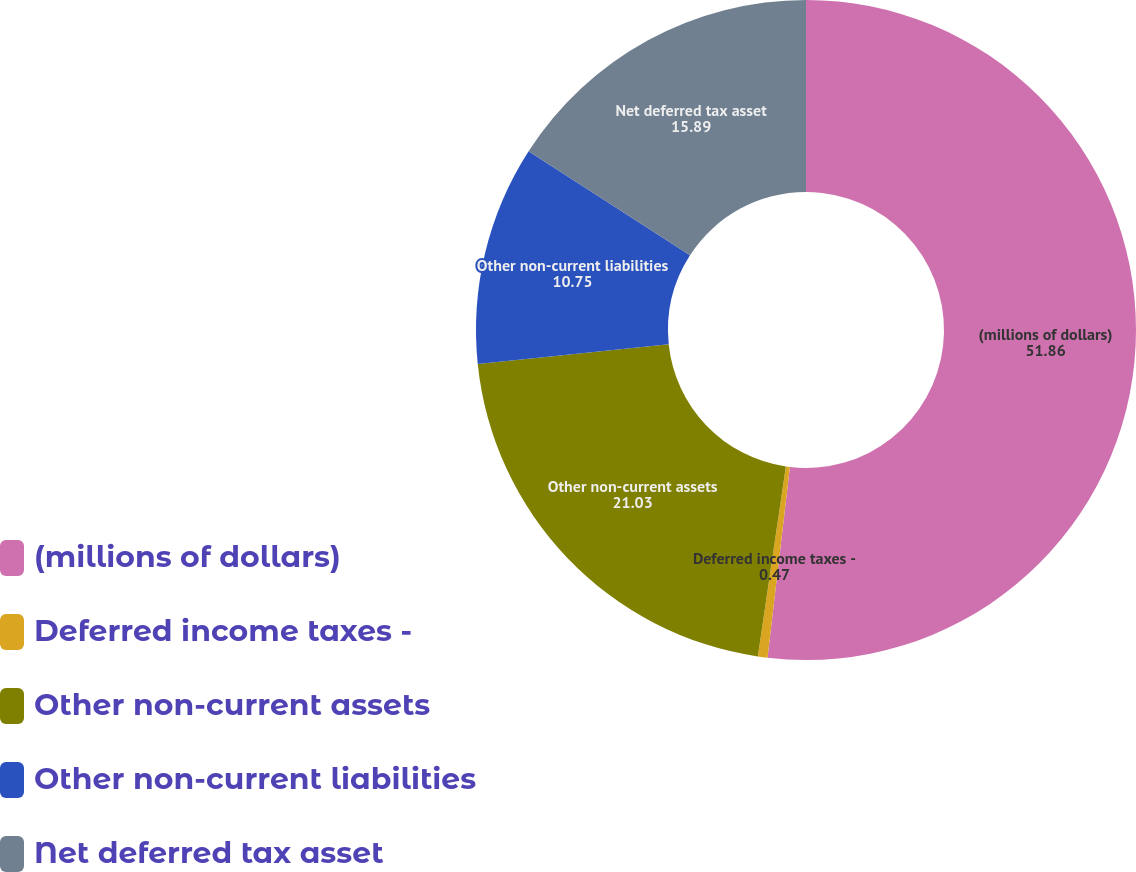<chart> <loc_0><loc_0><loc_500><loc_500><pie_chart><fcel>(millions of dollars)<fcel>Deferred income taxes -<fcel>Other non-current assets<fcel>Other non-current liabilities<fcel>Net deferred tax asset<nl><fcel>51.86%<fcel>0.47%<fcel>21.03%<fcel>10.75%<fcel>15.89%<nl></chart> 